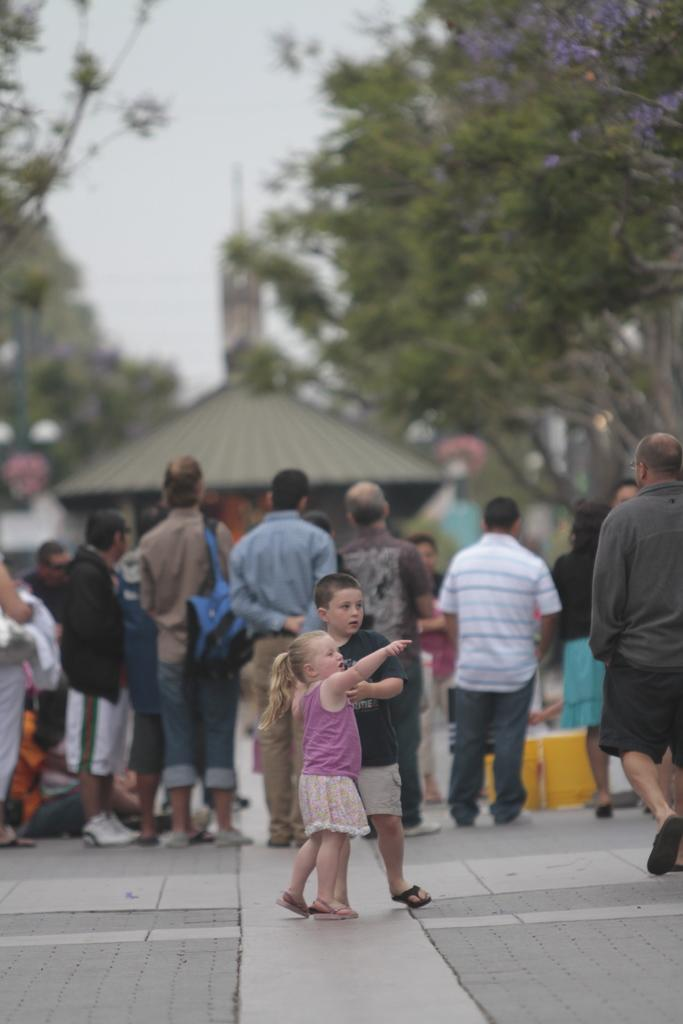What is happening in the image? There are people on the road in the image. What can be seen in the background of the image? There is a shed visible in the background of the image. What type of natural environment is present in the image? There are trees around the area in the image. How many basins are visible in the image? There are no basins present in the image. What type of ball is being used by the people in the image? There is no ball present in the image; the people are simply on the road. 